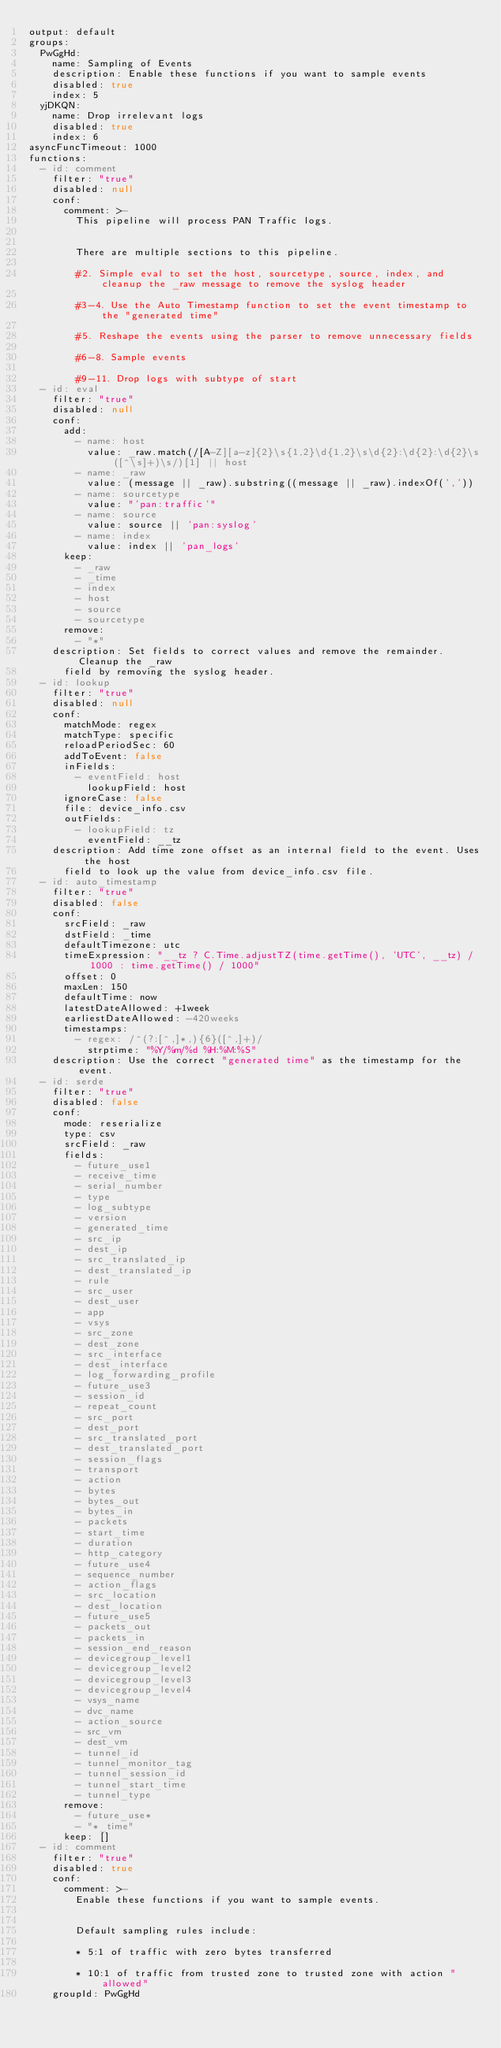<code> <loc_0><loc_0><loc_500><loc_500><_YAML_>output: default
groups:
  PwGgHd:
    name: Sampling of Events
    description: Enable these functions if you want to sample events
    disabled: true
    index: 5
  yjDKQN:
    name: Drop irrelevant logs
    disabled: true
    index: 6
asyncFuncTimeout: 1000
functions:
  - id: comment
    filter: "true"
    disabled: null
    conf:
      comment: >-
        This pipeline will process PAN Traffic logs.


        There are multiple sections to this pipeline.

        #2. Simple eval to set the host, sourcetype, source, index, and cleanup the _raw message to remove the syslog header

        #3-4. Use the Auto Timestamp function to set the event timestamp to the "generated time"

        #5. Reshape the events using the parser to remove unnecessary fields

        #6-8. Sample events

        #9-11. Drop logs with subtype of start
  - id: eval
    filter: "true"
    disabled: null
    conf:
      add:
        - name: host
          value: _raw.match(/[A-Z][a-z]{2}\s{1,2}\d{1,2}\s\d{2}:\d{2}:\d{2}\s([^\s]+)\s/)[1] || host
        - name: _raw
          value: (message || _raw).substring((message || _raw).indexOf(','))
        - name: sourcetype
          value: "'pan:traffic'"
        - name: source
          value: source || 'pan:syslog'
        - name: index
          value: index || 'pan_logs'
      keep:
        - _raw
        - _time
        - index
        - host
        - source
        - sourcetype
      remove:
        - "*"
    description: Set fields to correct values and remove the remainder. Cleanup the _raw
      field by removing the syslog header.
  - id: lookup
    filter: "true"
    disabled: null
    conf:
      matchMode: regex
      matchType: specific
      reloadPeriodSec: 60
      addToEvent: false
      inFields:
        - eventField: host
          lookupField: host
      ignoreCase: false
      file: device_info.csv
      outFields:
        - lookupField: tz
          eventField: __tz
    description: Add time zone offset as an internal field to the event. Uses the host
      field to look up the value from device_info.csv file.
  - id: auto_timestamp
    filter: "true"
    disabled: false
    conf:
      srcField: _raw
      dstField: _time
      defaultTimezone: utc
      timeExpression: "__tz ? C.Time.adjustTZ(time.getTime(), 'UTC', __tz) / 1000 : time.getTime() / 1000"
      offset: 0
      maxLen: 150
      defaultTime: now
      latestDateAllowed: +1week
      earliestDateAllowed: -420weeks
      timestamps:
        - regex: /^(?:[^,]*,){6}([^,]+)/
          strptime: "%Y/%m/%d %H:%M:%S"
    description: Use the correct "generated time" as the timestamp for the event.
  - id: serde
    filter: "true"
    disabled: false
    conf:
      mode: reserialize
      type: csv
      srcField: _raw
      fields:
        - future_use1
        - receive_time
        - serial_number
        - type
        - log_subtype
        - version
        - generated_time
        - src_ip
        - dest_ip
        - src_translated_ip
        - dest_translated_ip
        - rule
        - src_user
        - dest_user
        - app
        - vsys
        - src_zone
        - dest_zone
        - src_interface
        - dest_interface
        - log_forwarding_profile
        - future_use3
        - session_id
        - repeat_count
        - src_port
        - dest_port
        - src_translated_port
        - dest_translated_port
        - session_flags
        - transport
        - action
        - bytes
        - bytes_out
        - bytes_in
        - packets
        - start_time
        - duration
        - http_category
        - future_use4
        - sequence_number
        - action_flags
        - src_location
        - dest_location
        - future_use5
        - packets_out
        - packets_in
        - session_end_reason
        - devicegroup_level1
        - devicegroup_level2
        - devicegroup_level3
        - devicegroup_level4
        - vsys_name
        - dvc_name
        - action_source
        - src_vm
        - dest_vm
        - tunnel_id
        - tunnel_monitor_tag
        - tunnel_session_id
        - tunnel_start_time
        - tunnel_type
      remove:
        - future_use*
        - "*_time"
      keep: []
  - id: comment
    filter: "true"
    disabled: true
    conf:
      comment: >-
        Enable these functions if you want to sample events.


        Default sampling rules include:

        * 5:1 of traffic with zero bytes transferred

        * 10:1 of traffic from trusted zone to trusted zone with action "allowed"
    groupId: PwGgHd</code> 